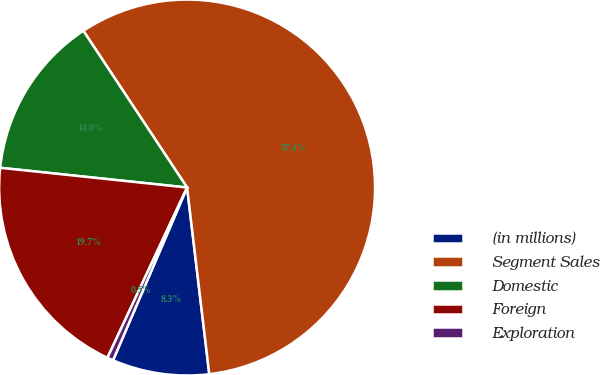<chart> <loc_0><loc_0><loc_500><loc_500><pie_chart><fcel>(in millions)<fcel>Segment Sales<fcel>Domestic<fcel>Foreign<fcel>Exploration<nl><fcel>8.33%<fcel>57.42%<fcel>14.02%<fcel>19.71%<fcel>0.52%<nl></chart> 